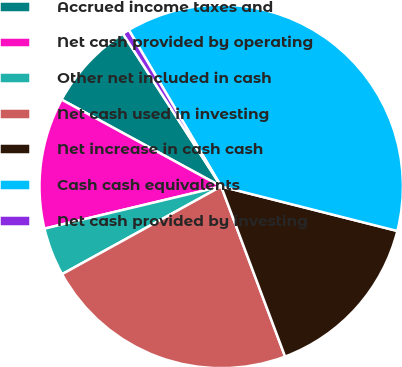<chart> <loc_0><loc_0><loc_500><loc_500><pie_chart><fcel>Accrued income taxes and<fcel>Net cash provided by operating<fcel>Other net included in cash<fcel>Net cash used in investing<fcel>Net increase in cash cash<fcel>Cash cash equivalents<fcel>Net cash provided by investing<nl><fcel>7.97%<fcel>11.66%<fcel>4.29%<fcel>22.7%<fcel>15.34%<fcel>37.43%<fcel>0.61%<nl></chart> 